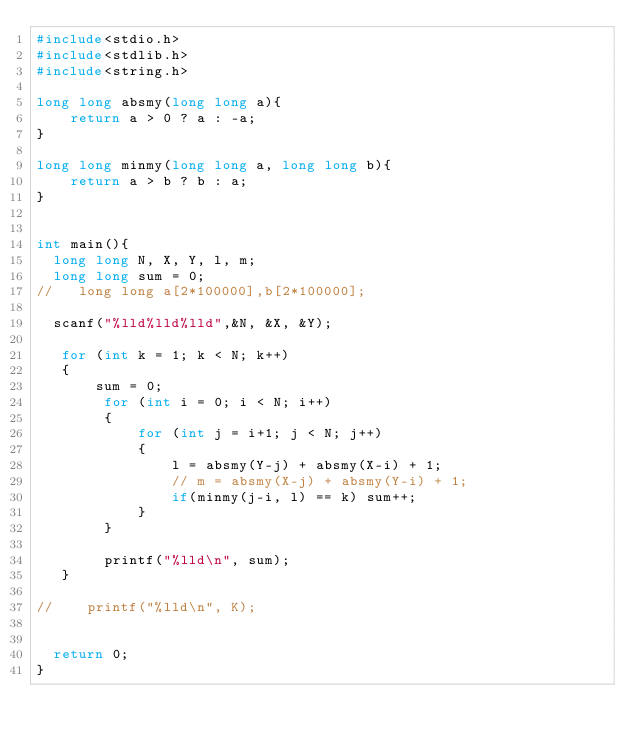Convert code to text. <code><loc_0><loc_0><loc_500><loc_500><_C_>#include<stdio.h>
#include<stdlib.h>
#include<string.h>
 
long long absmy(long long a){
    return a > 0 ? a : -a;
}

long long minmy(long long a, long long b){
    return a > b ? b : a;
}


int main(){
  long long N, X, Y, l, m;
  long long sum = 0;
//   long long a[2*100000],b[2*100000];

  scanf("%lld%lld%lld",&N, &X, &Y);

   for (int k = 1; k < N; k++)
   {
       sum = 0;
        for (int i = 0; i < N; i++)
        {
            for (int j = i+1; j < N; j++)
            {
                l = absmy(Y-j) + absmy(X-i) + 1;
                // m = absmy(X-j) + absmy(Y-i) + 1;
                if(minmy(j-i, l) == k) sum++;
            }
        }
        
        printf("%lld\n", sum);
   }
   
//    printf("%lld\n", K);
  

  return 0;
}</code> 